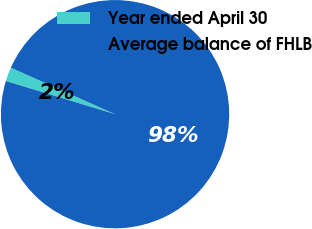Convert chart. <chart><loc_0><loc_0><loc_500><loc_500><pie_chart><fcel>Year ended April 30<fcel>Average balance of FHLB<nl><fcel>1.99%<fcel>98.01%<nl></chart> 